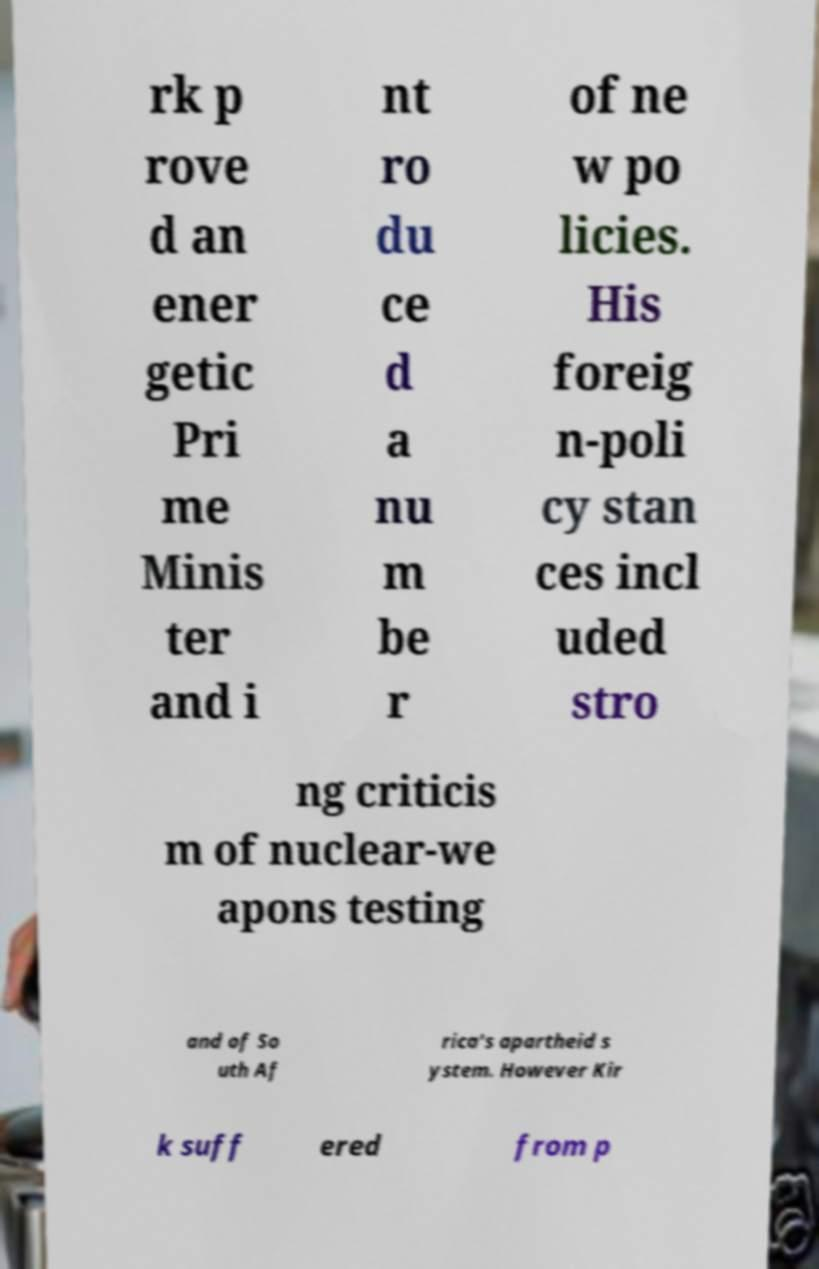Please read and relay the text visible in this image. What does it say? rk p rove d an ener getic Pri me Minis ter and i nt ro du ce d a nu m be r of ne w po licies. His foreig n-poli cy stan ces incl uded stro ng criticis m of nuclear-we apons testing and of So uth Af rica's apartheid s ystem. However Kir k suff ered from p 